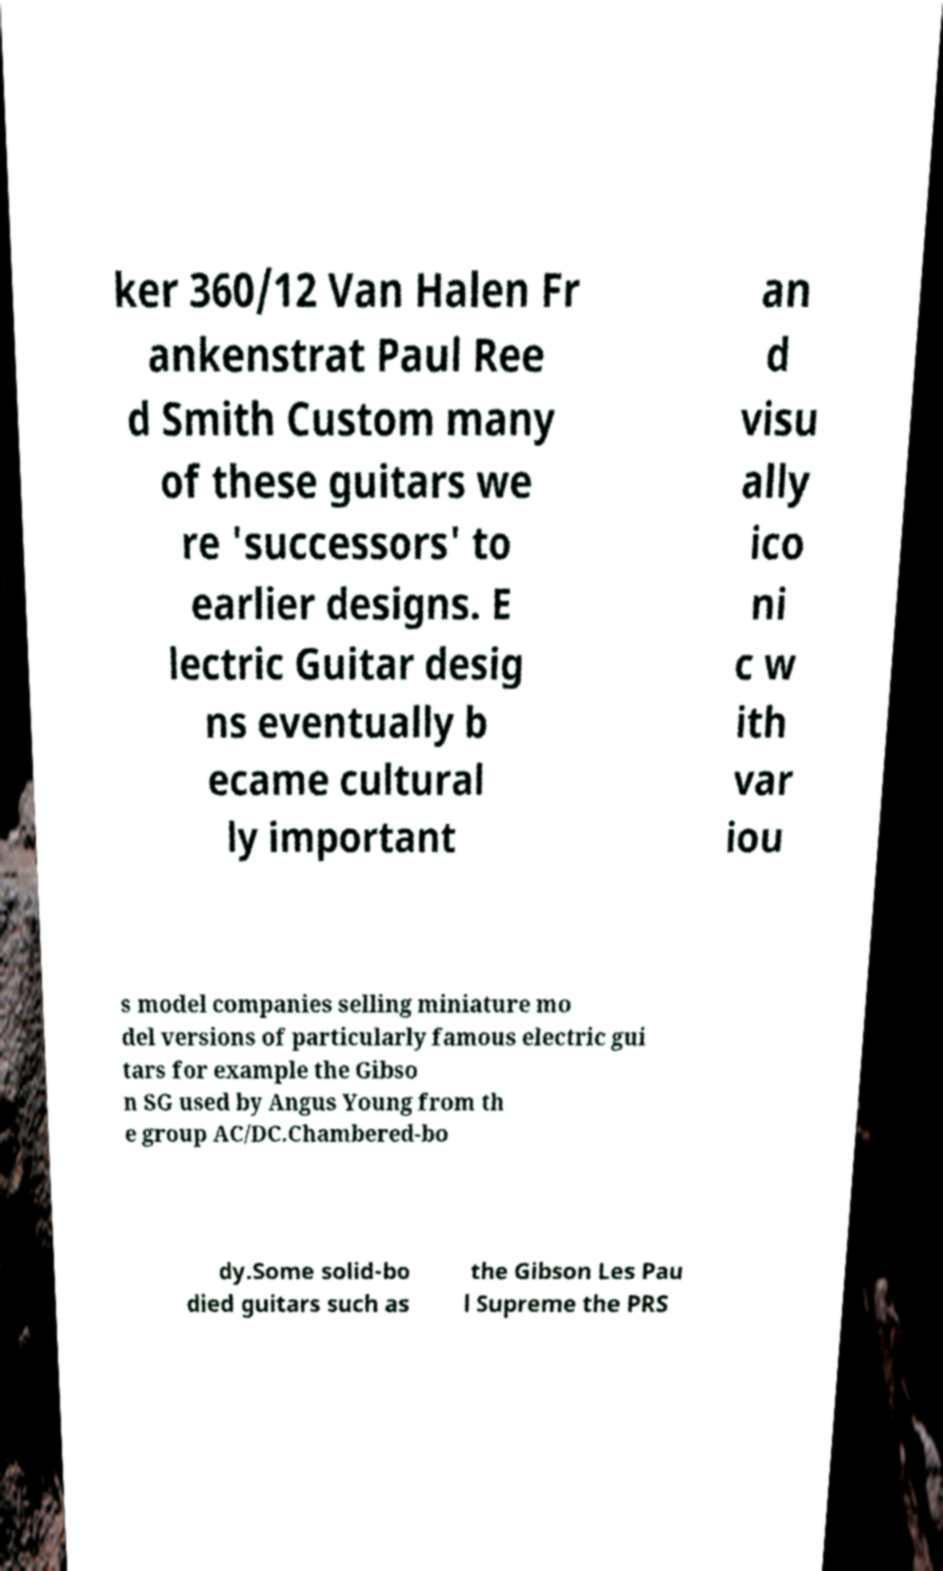Could you extract and type out the text from this image? ker 360/12 Van Halen Fr ankenstrat Paul Ree d Smith Custom many of these guitars we re 'successors' to earlier designs. E lectric Guitar desig ns eventually b ecame cultural ly important an d visu ally ico ni c w ith var iou s model companies selling miniature mo del versions of particularly famous electric gui tars for example the Gibso n SG used by Angus Young from th e group AC/DC.Chambered-bo dy.Some solid-bo died guitars such as the Gibson Les Pau l Supreme the PRS 